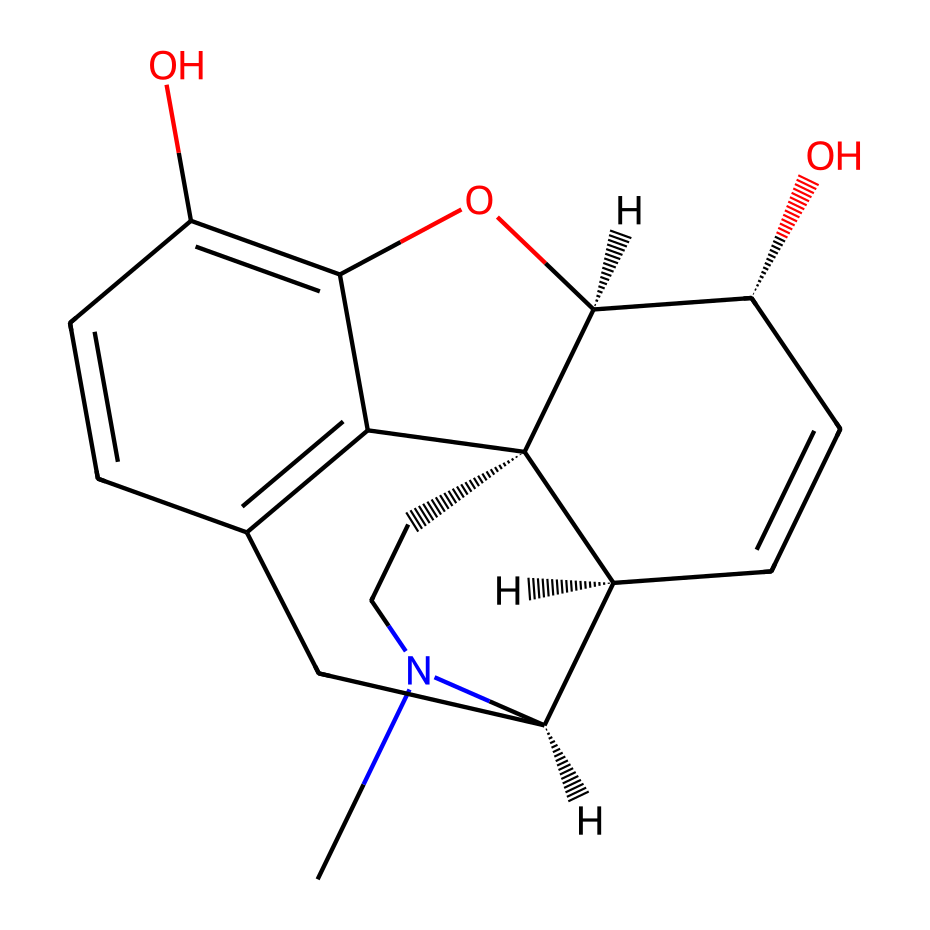What is the main functional group present in morphine? Analyzing the chemical structure (SMILES), we can identify the hydroxyl (–OH) groups and the nitrogen atom, which indicate the presence of alcohol and amine functional groups. However, the main functional group that characterizes morphine is the phenolic hydroxyl group.
Answer: phenolic hydroxyl How many oxygen atoms are in the structure of morphine? The SMILES representation shows that there are two –OH (hydroxyl) groups, each containing one oxygen atom, resulting in a total of two oxygen atoms present in the structure.
Answer: 2 What type of chemical compound is morphine categorized as? Based on the presence of nitrogen and its structure, morphine is classified as an alkaloid, which are naturally occurring compounds often derived from plants and known for their pharmacological properties.
Answer: alkaloid Does morphine have a chiral center? The SMILES includes notations such as [C@], indicating that there are asymmetric carbon atoms in the structure. This indicates that morphine has at least one chiral center, making it optically active.
Answer: yes What are the total number of carbon atoms in morphine? Counting the carbon (C) atoms in the SMILES representation, we see that there are 17 carbon atoms present in the overall structure of morphine.
Answer: 17 What type of bonds are primarily present in morphine? The structure of morphine comprises various types of bonds, notably single (sigma) bonds connecting carbon atoms and functional groups, and some double bonds between carbon atoms in rings. The majority of connections are single covalent bonds.
Answer: single covalent bonds 